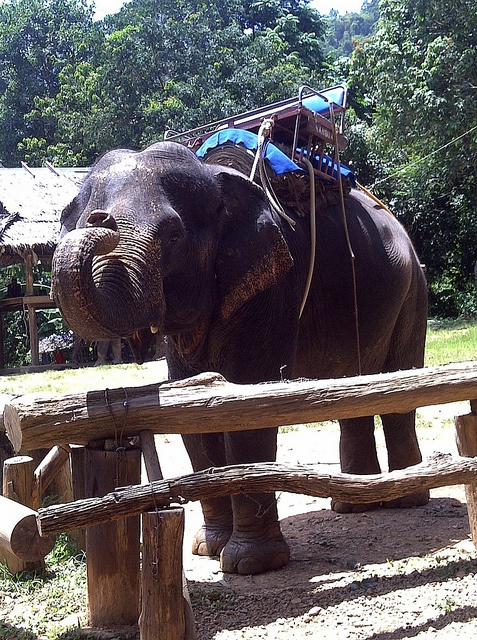Describe the objects in this image and their specific colors. I can see elephant in ivory, black, maroon, white, and gray tones and bench in ivory, gray, white, black, and navy tones in this image. 